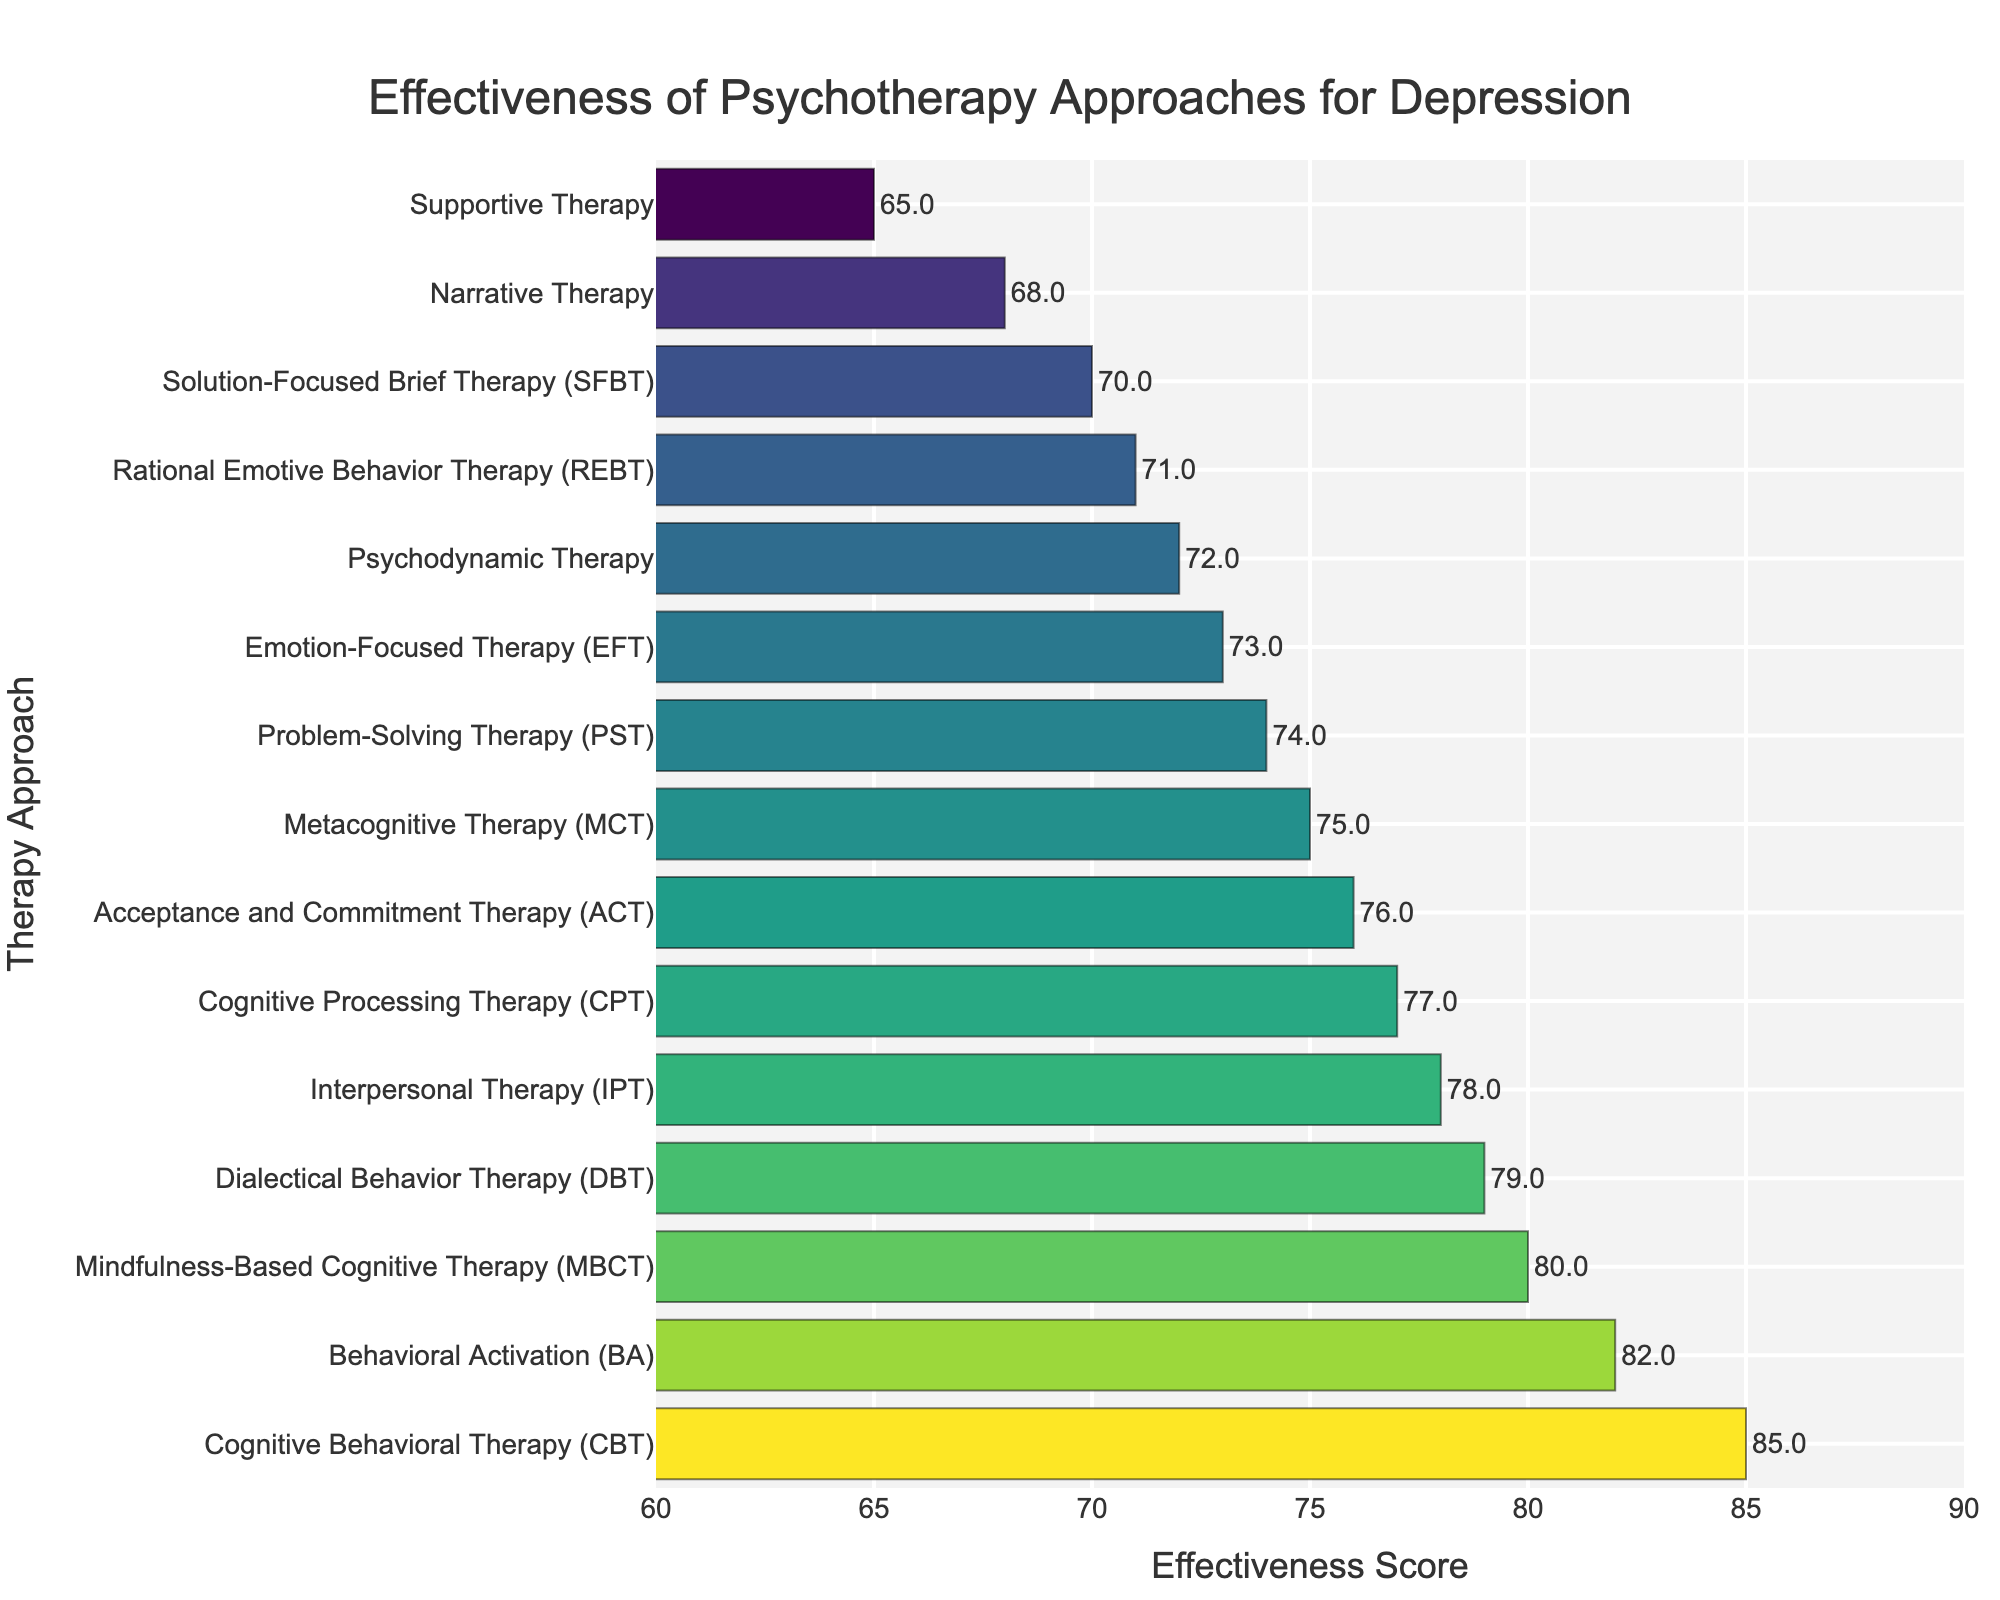Which psychotherapy approach has the highest effectiveness score? Locate the topmost bar in the figure which represents the highest effectiveness score among the psychotherapy approaches.
Answer: Cognitive Behavioral Therapy (CBT) Which three approaches score above 80 in effectiveness? Identify the bars that represent scores above 80 and list the corresponding psychotherapy approaches.
Answer: Cognitive Behavioral Therapy (CBT), Behavioral Activation (BA), Mindfulness-Based Cognitive Therapy (MBCT) What is the effectiveness score difference between the highest and lowest scoring therapies? Subtract the effectiveness score of the lowest scoring therapy from the highest scoring therapy. The highest score is 85 (CBT), and the lowest score is 65 (Supportive Therapy), so the difference is 85 - 65.
Answer: 20 How many therapies have an effectiveness score of 75 or above? Count the number of bars representing therapies with effectiveness scores of 75 or higher.
Answer: 10 Which therapy approach is closest in effectiveness score to Interpersonal Therapy (IPT)? Find the effectiveness score of IPT (78) and look for the bar closest to this score.
Answer: Dialectical Behavior Therapy (DBT), with a score of 79 What is the average effectiveness score of all therapies? Sum up all the effectiveness scores and divide by the total number of therapies (15). The calculation is (85 + 78 + 72 + 80 + 76 + 82 + 74 + 79 + 71 + 68 + 70 + 77 + 73 + 75 + 65) / 15.
Answer: 74.2 Which two therapies have the smallest difference in their effectiveness scores? Look for therapies with scores closest to each other. CPT (77) and ACT (76) have the smallest difference (77 - 76).
Answer: Cognitive Processing Therapy (CPT) and Acceptance and Commitment Therapy (ACT) What is the median effectiveness score of the psychotherapy approaches? Sort the scores in ascending order and find the middle value. The ordered scores are 65, 68, 70, 71, 72, 73, 74, 75, 76, 77, 78, 79, 80, 82, 85. The median score is the 8th value, which is 75.
Answer: 75 Which psychotherapy approaches have effectiveness scores below the average effectiveness score? Find the average effectiveness score (74.2) and list the therapies with scores below this average.
Answer: Rational Emotive Behavior Therapy (REBT), Narrative Therapy, Solution-Focused Brief Therapy (SFBT), Supportive Therapy What is the sum of the effectiveness scores for the three least effective therapies? Add the effectiveness scores of Supportive Therapy (65), Narrative Therapy (68), and Solution-Focused Brief Therapy (70). The sum is 65 + 68 + 70.
Answer: 203 